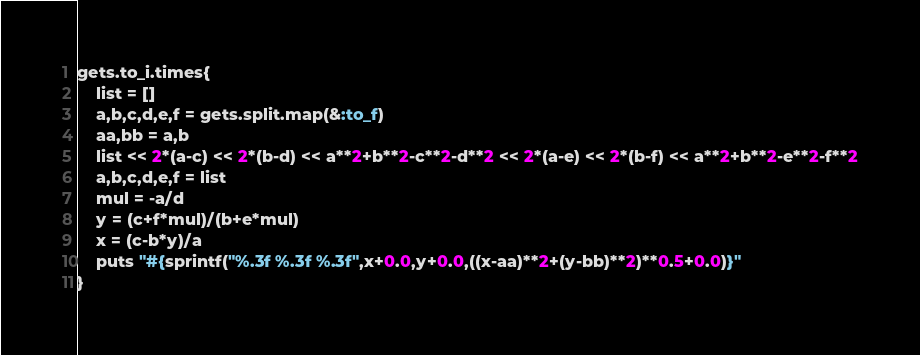<code> <loc_0><loc_0><loc_500><loc_500><_Ruby_>gets.to_i.times{
	list = []
	a,b,c,d,e,f = gets.split.map(&:to_f)
	aa,bb = a,b
	list << 2*(a-c) << 2*(b-d) << a**2+b**2-c**2-d**2 << 2*(a-e) << 2*(b-f) << a**2+b**2-e**2-f**2
	a,b,c,d,e,f = list
	mul = -a/d
	y = (c+f*mul)/(b+e*mul)
	x = (c-b*y)/a
	puts "#{sprintf("%.3f %.3f %.3f",x+0.0,y+0.0,((x-aa)**2+(y-bb)**2)**0.5+0.0)}"
}</code> 